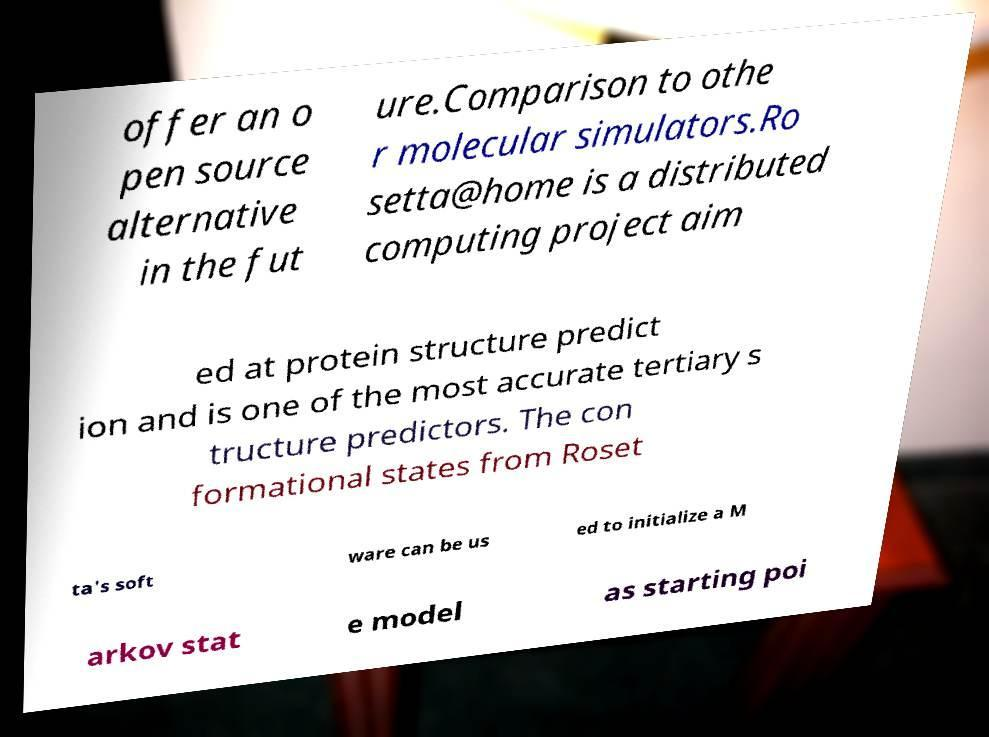Could you extract and type out the text from this image? offer an o pen source alternative in the fut ure.Comparison to othe r molecular simulators.Ro setta@home is a distributed computing project aim ed at protein structure predict ion and is one of the most accurate tertiary s tructure predictors. The con formational states from Roset ta's soft ware can be us ed to initialize a M arkov stat e model as starting poi 